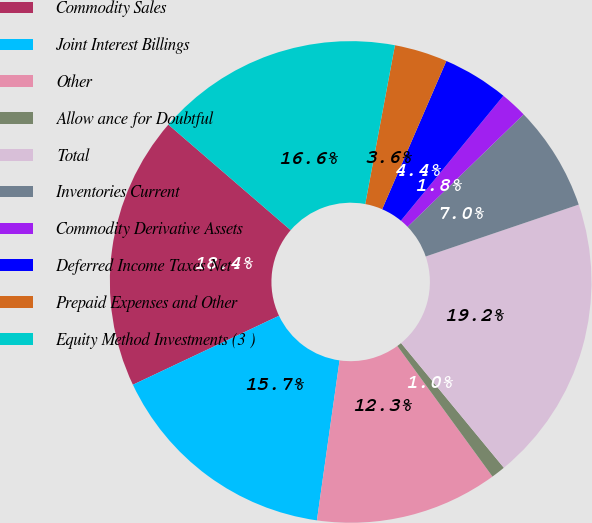Convert chart. <chart><loc_0><loc_0><loc_500><loc_500><pie_chart><fcel>Commodity Sales<fcel>Joint Interest Billings<fcel>Other<fcel>Allow ance for Doubtful<fcel>Total<fcel>Inventories Current<fcel>Commodity Derivative Assets<fcel>Deferred Income Taxes Net<fcel>Prepaid Expenses and Other<fcel>Equity Method Investments (3 )<nl><fcel>18.35%<fcel>15.74%<fcel>12.26%<fcel>0.95%<fcel>19.23%<fcel>7.04%<fcel>1.82%<fcel>4.43%<fcel>3.56%<fcel>16.61%<nl></chart> 